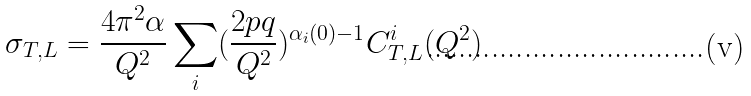<formula> <loc_0><loc_0><loc_500><loc_500>\sigma _ { T , L } = { \frac { 4 \pi ^ { 2 } \alpha } { Q ^ { 2 } } } \sum _ { i } ( { \frac { 2 p q } { Q ^ { 2 } } } ) ^ { \alpha _ { i } ( 0 ) - 1 } C _ { T , L } ^ { i } ( Q ^ { 2 } )</formula> 